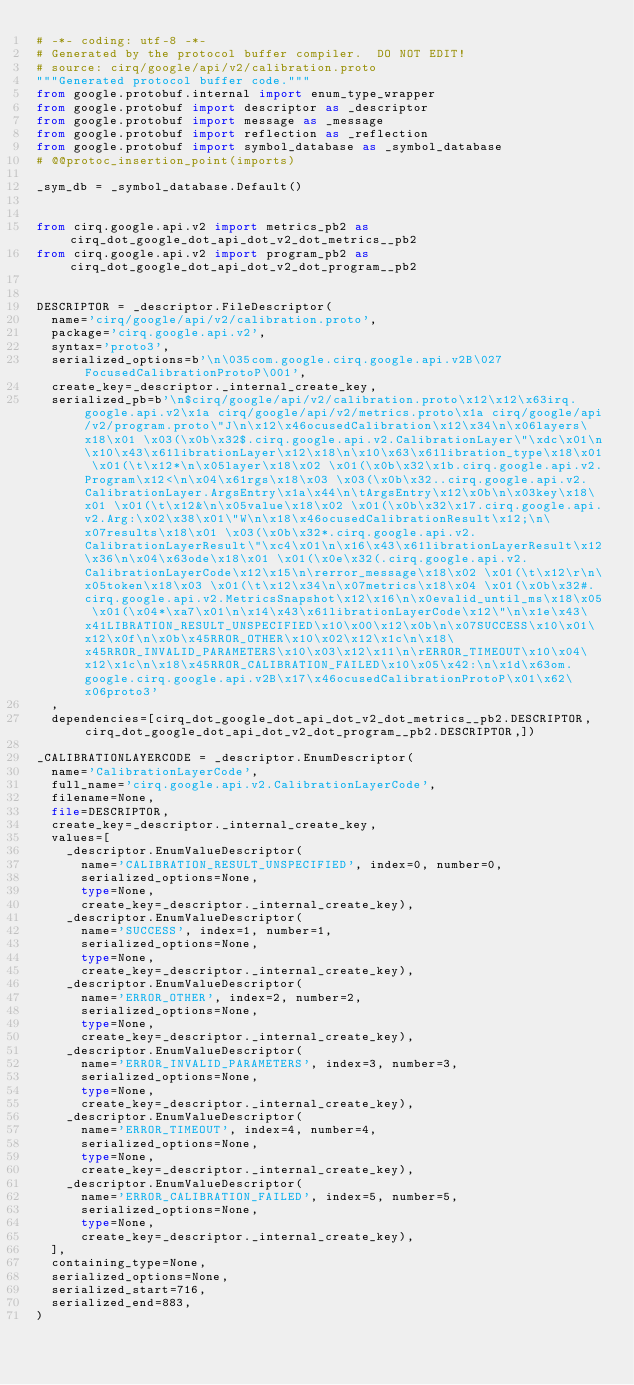Convert code to text. <code><loc_0><loc_0><loc_500><loc_500><_Python_># -*- coding: utf-8 -*-
# Generated by the protocol buffer compiler.  DO NOT EDIT!
# source: cirq/google/api/v2/calibration.proto
"""Generated protocol buffer code."""
from google.protobuf.internal import enum_type_wrapper
from google.protobuf import descriptor as _descriptor
from google.protobuf import message as _message
from google.protobuf import reflection as _reflection
from google.protobuf import symbol_database as _symbol_database
# @@protoc_insertion_point(imports)

_sym_db = _symbol_database.Default()


from cirq.google.api.v2 import metrics_pb2 as cirq_dot_google_dot_api_dot_v2_dot_metrics__pb2
from cirq.google.api.v2 import program_pb2 as cirq_dot_google_dot_api_dot_v2_dot_program__pb2


DESCRIPTOR = _descriptor.FileDescriptor(
  name='cirq/google/api/v2/calibration.proto',
  package='cirq.google.api.v2',
  syntax='proto3',
  serialized_options=b'\n\035com.google.cirq.google.api.v2B\027FocusedCalibrationProtoP\001',
  create_key=_descriptor._internal_create_key,
  serialized_pb=b'\n$cirq/google/api/v2/calibration.proto\x12\x12\x63irq.google.api.v2\x1a cirq/google/api/v2/metrics.proto\x1a cirq/google/api/v2/program.proto\"J\n\x12\x46ocusedCalibration\x12\x34\n\x06layers\x18\x01 \x03(\x0b\x32$.cirq.google.api.v2.CalibrationLayer\"\xdc\x01\n\x10\x43\x61librationLayer\x12\x18\n\x10\x63\x61libration_type\x18\x01 \x01(\t\x12*\n\x05layer\x18\x02 \x01(\x0b\x32\x1b.cirq.google.api.v2.Program\x12<\n\x04\x61rgs\x18\x03 \x03(\x0b\x32..cirq.google.api.v2.CalibrationLayer.ArgsEntry\x1a\x44\n\tArgsEntry\x12\x0b\n\x03key\x18\x01 \x01(\t\x12&\n\x05value\x18\x02 \x01(\x0b\x32\x17.cirq.google.api.v2.Arg:\x02\x38\x01\"W\n\x18\x46ocusedCalibrationResult\x12;\n\x07results\x18\x01 \x03(\x0b\x32*.cirq.google.api.v2.CalibrationLayerResult\"\xc4\x01\n\x16\x43\x61librationLayerResult\x12\x36\n\x04\x63ode\x18\x01 \x01(\x0e\x32(.cirq.google.api.v2.CalibrationLayerCode\x12\x15\n\rerror_message\x18\x02 \x01(\t\x12\r\n\x05token\x18\x03 \x01(\t\x12\x34\n\x07metrics\x18\x04 \x01(\x0b\x32#.cirq.google.api.v2.MetricsSnapshot\x12\x16\n\x0evalid_until_ms\x18\x05 \x01(\x04*\xa7\x01\n\x14\x43\x61librationLayerCode\x12\"\n\x1e\x43\x41LIBRATION_RESULT_UNSPECIFIED\x10\x00\x12\x0b\n\x07SUCCESS\x10\x01\x12\x0f\n\x0b\x45RROR_OTHER\x10\x02\x12\x1c\n\x18\x45RROR_INVALID_PARAMETERS\x10\x03\x12\x11\n\rERROR_TIMEOUT\x10\x04\x12\x1c\n\x18\x45RROR_CALIBRATION_FAILED\x10\x05\x42:\n\x1d\x63om.google.cirq.google.api.v2B\x17\x46ocusedCalibrationProtoP\x01\x62\x06proto3'
  ,
  dependencies=[cirq_dot_google_dot_api_dot_v2_dot_metrics__pb2.DESCRIPTOR,cirq_dot_google_dot_api_dot_v2_dot_program__pb2.DESCRIPTOR,])

_CALIBRATIONLAYERCODE = _descriptor.EnumDescriptor(
  name='CalibrationLayerCode',
  full_name='cirq.google.api.v2.CalibrationLayerCode',
  filename=None,
  file=DESCRIPTOR,
  create_key=_descriptor._internal_create_key,
  values=[
    _descriptor.EnumValueDescriptor(
      name='CALIBRATION_RESULT_UNSPECIFIED', index=0, number=0,
      serialized_options=None,
      type=None,
      create_key=_descriptor._internal_create_key),
    _descriptor.EnumValueDescriptor(
      name='SUCCESS', index=1, number=1,
      serialized_options=None,
      type=None,
      create_key=_descriptor._internal_create_key),
    _descriptor.EnumValueDescriptor(
      name='ERROR_OTHER', index=2, number=2,
      serialized_options=None,
      type=None,
      create_key=_descriptor._internal_create_key),
    _descriptor.EnumValueDescriptor(
      name='ERROR_INVALID_PARAMETERS', index=3, number=3,
      serialized_options=None,
      type=None,
      create_key=_descriptor._internal_create_key),
    _descriptor.EnumValueDescriptor(
      name='ERROR_TIMEOUT', index=4, number=4,
      serialized_options=None,
      type=None,
      create_key=_descriptor._internal_create_key),
    _descriptor.EnumValueDescriptor(
      name='ERROR_CALIBRATION_FAILED', index=5, number=5,
      serialized_options=None,
      type=None,
      create_key=_descriptor._internal_create_key),
  ],
  containing_type=None,
  serialized_options=None,
  serialized_start=716,
  serialized_end=883,
)</code> 